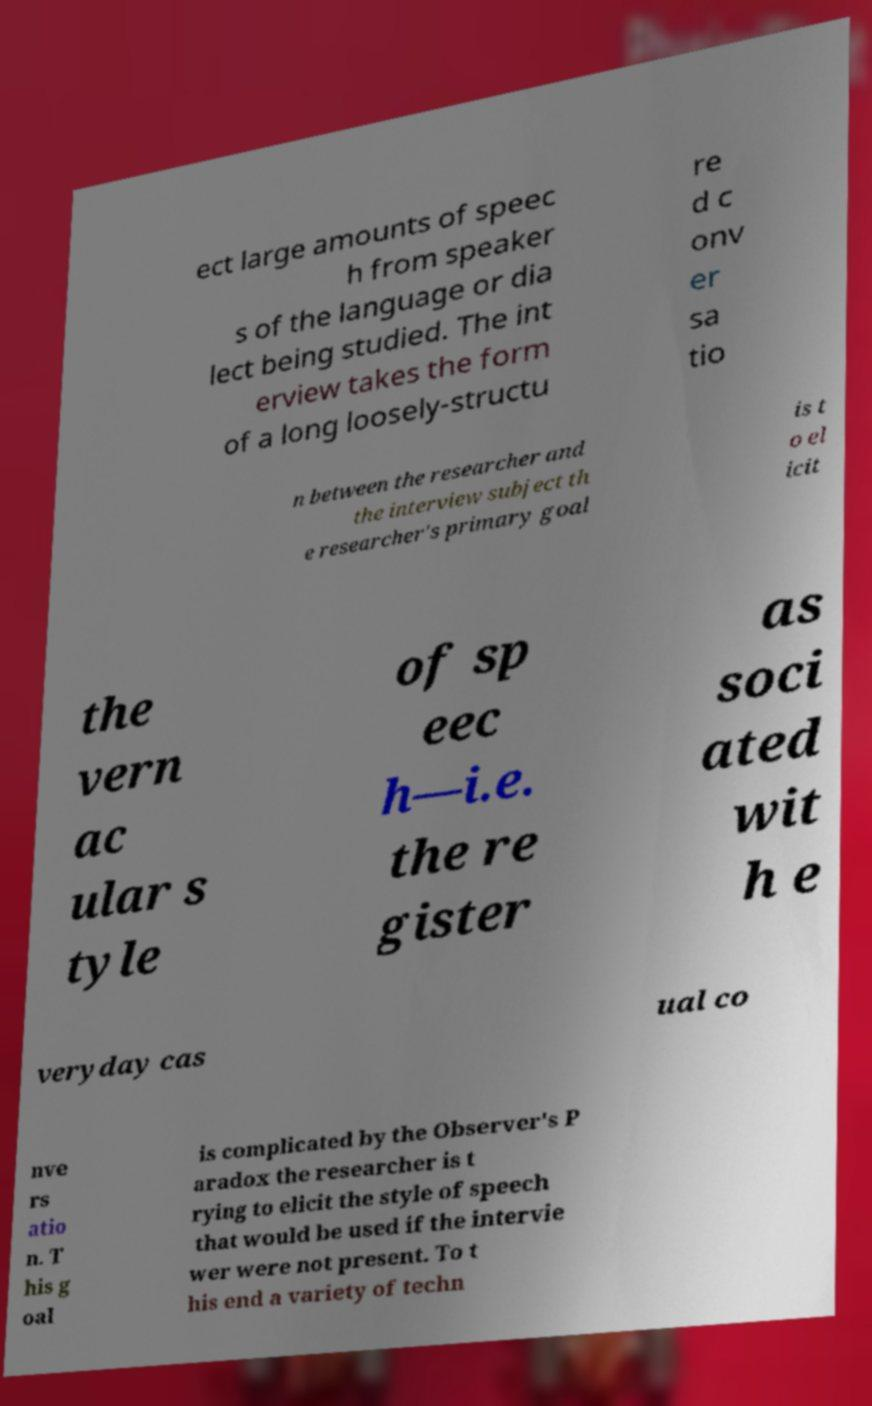Could you assist in decoding the text presented in this image and type it out clearly? ect large amounts of speec h from speaker s of the language or dia lect being studied. The int erview takes the form of a long loosely-structu re d c onv er sa tio n between the researcher and the interview subject th e researcher's primary goal is t o el icit the vern ac ular s tyle of sp eec h—i.e. the re gister as soci ated wit h e veryday cas ual co nve rs atio n. T his g oal is complicated by the Observer's P aradox the researcher is t rying to elicit the style of speech that would be used if the intervie wer were not present. To t his end a variety of techn 